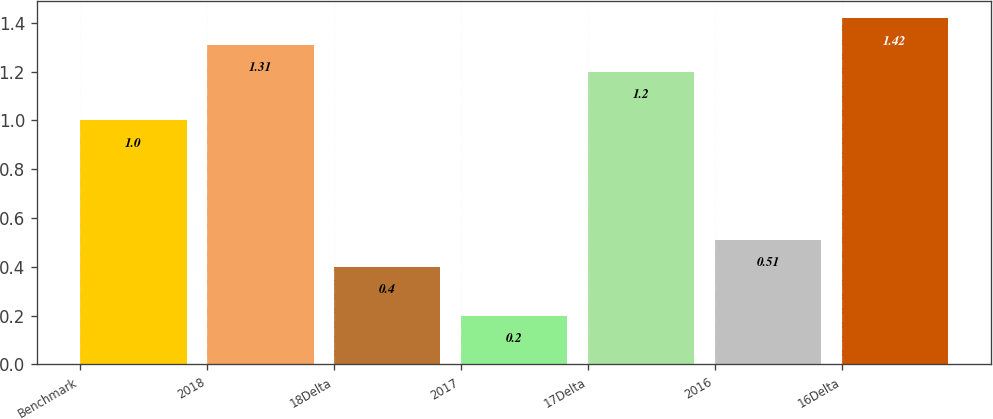Convert chart. <chart><loc_0><loc_0><loc_500><loc_500><bar_chart><fcel>Benchmark<fcel>2018<fcel>18Delta<fcel>2017<fcel>17Delta<fcel>2016<fcel>16Delta<nl><fcel>1<fcel>1.31<fcel>0.4<fcel>0.2<fcel>1.2<fcel>0.51<fcel>1.42<nl></chart> 